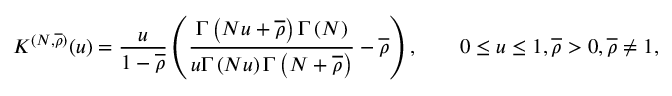Convert formula to latex. <formula><loc_0><loc_0><loc_500><loc_500>K ^ { ( N , \overline { \rho } ) } ( u ) = \frac { u } { 1 - \overline { \rho } } \left ( \frac { \Gamma \left ( N u + \overline { \rho } \right ) \Gamma \left ( N \right ) } { u \Gamma \left ( N u \right ) \Gamma \left ( N + \overline { \rho } \right ) } - \overline { \rho } \right ) , \quad 0 \leq u \leq 1 , \overline { \rho } > 0 , \overline { \rho } \neq 1 ,</formula> 